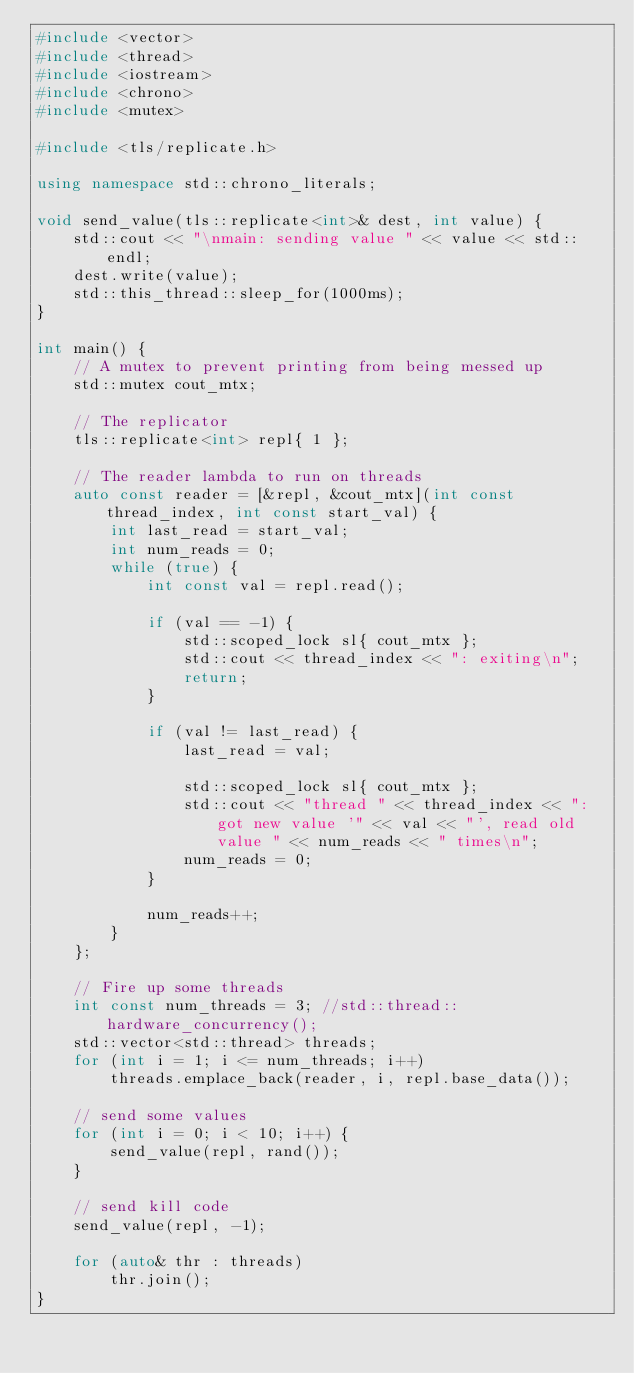<code> <loc_0><loc_0><loc_500><loc_500><_C++_>#include <vector>
#include <thread>
#include <iostream>
#include <chrono>
#include <mutex>

#include <tls/replicate.h>

using namespace std::chrono_literals;

void send_value(tls::replicate<int>& dest, int value) {
    std::cout << "\nmain: sending value " << value << std::endl;
    dest.write(value);
    std::this_thread::sleep_for(1000ms);
}

int main() {
    // A mutex to prevent printing from being messed up
    std::mutex cout_mtx;

    // The replicator
    tls::replicate<int> repl{ 1 };

    // The reader lambda to run on threads
    auto const reader = [&repl, &cout_mtx](int const thread_index, int const start_val) {
        int last_read = start_val;
        int num_reads = 0;
        while (true) {
            int const val = repl.read();

            if (val == -1) {
                std::scoped_lock sl{ cout_mtx };
                std::cout << thread_index << ": exiting\n";
                return;
            }

            if (val != last_read) {
                last_read = val;

                std::scoped_lock sl{ cout_mtx };
                std::cout << "thread " << thread_index << ": got new value '" << val << "', read old value " << num_reads << " times\n";
                num_reads = 0;
            }

            num_reads++;
        }
    };

    // Fire up some threads
    int const num_threads = 3; //std::thread::hardware_concurrency();
    std::vector<std::thread> threads;
    for (int i = 1; i <= num_threads; i++)
        threads.emplace_back(reader, i, repl.base_data());

    // send some values
    for (int i = 0; i < 10; i++) {
        send_value(repl, rand());
    }

    // send kill code
    send_value(repl, -1);

    for (auto& thr : threads)
        thr.join();
}
</code> 